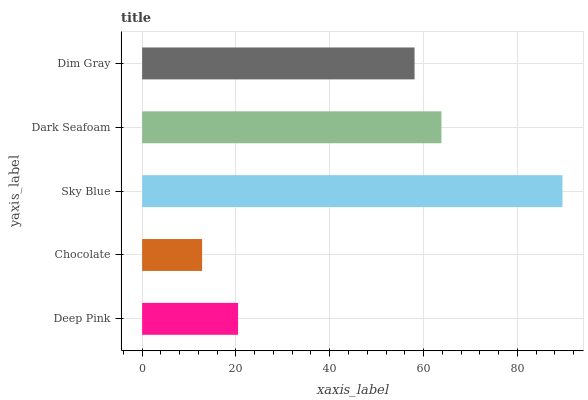Is Chocolate the minimum?
Answer yes or no. Yes. Is Sky Blue the maximum?
Answer yes or no. Yes. Is Sky Blue the minimum?
Answer yes or no. No. Is Chocolate the maximum?
Answer yes or no. No. Is Sky Blue greater than Chocolate?
Answer yes or no. Yes. Is Chocolate less than Sky Blue?
Answer yes or no. Yes. Is Chocolate greater than Sky Blue?
Answer yes or no. No. Is Sky Blue less than Chocolate?
Answer yes or no. No. Is Dim Gray the high median?
Answer yes or no. Yes. Is Dim Gray the low median?
Answer yes or no. Yes. Is Deep Pink the high median?
Answer yes or no. No. Is Dark Seafoam the low median?
Answer yes or no. No. 